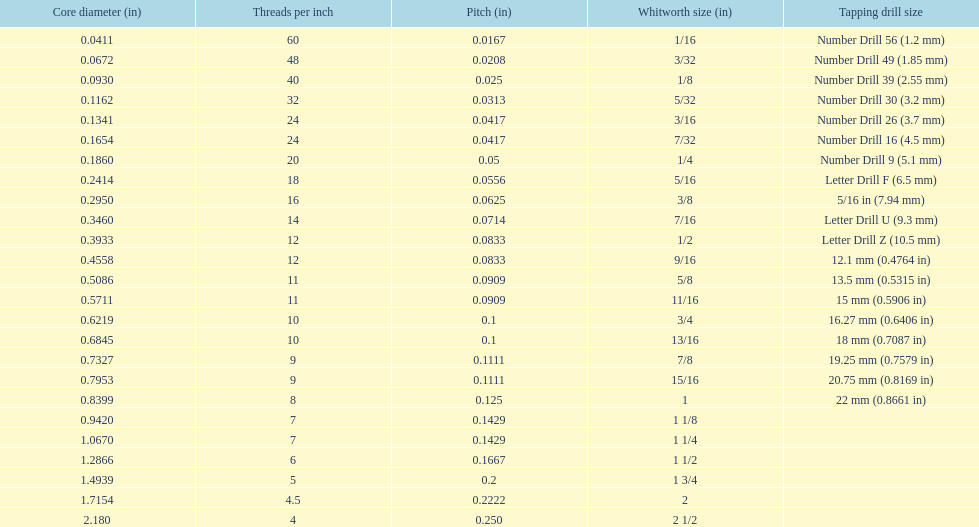What is the total of the first two core diameters? 0.1083. 